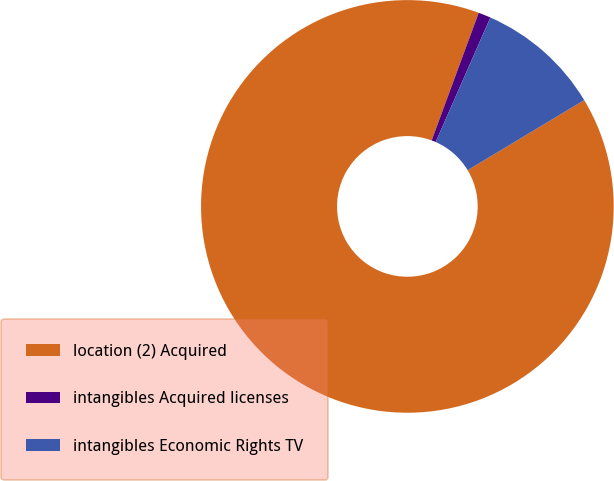Convert chart to OTSL. <chart><loc_0><loc_0><loc_500><loc_500><pie_chart><fcel>location (2) Acquired<fcel>intangibles Acquired licenses<fcel>intangibles Economic Rights TV<nl><fcel>89.23%<fcel>0.97%<fcel>9.8%<nl></chart> 